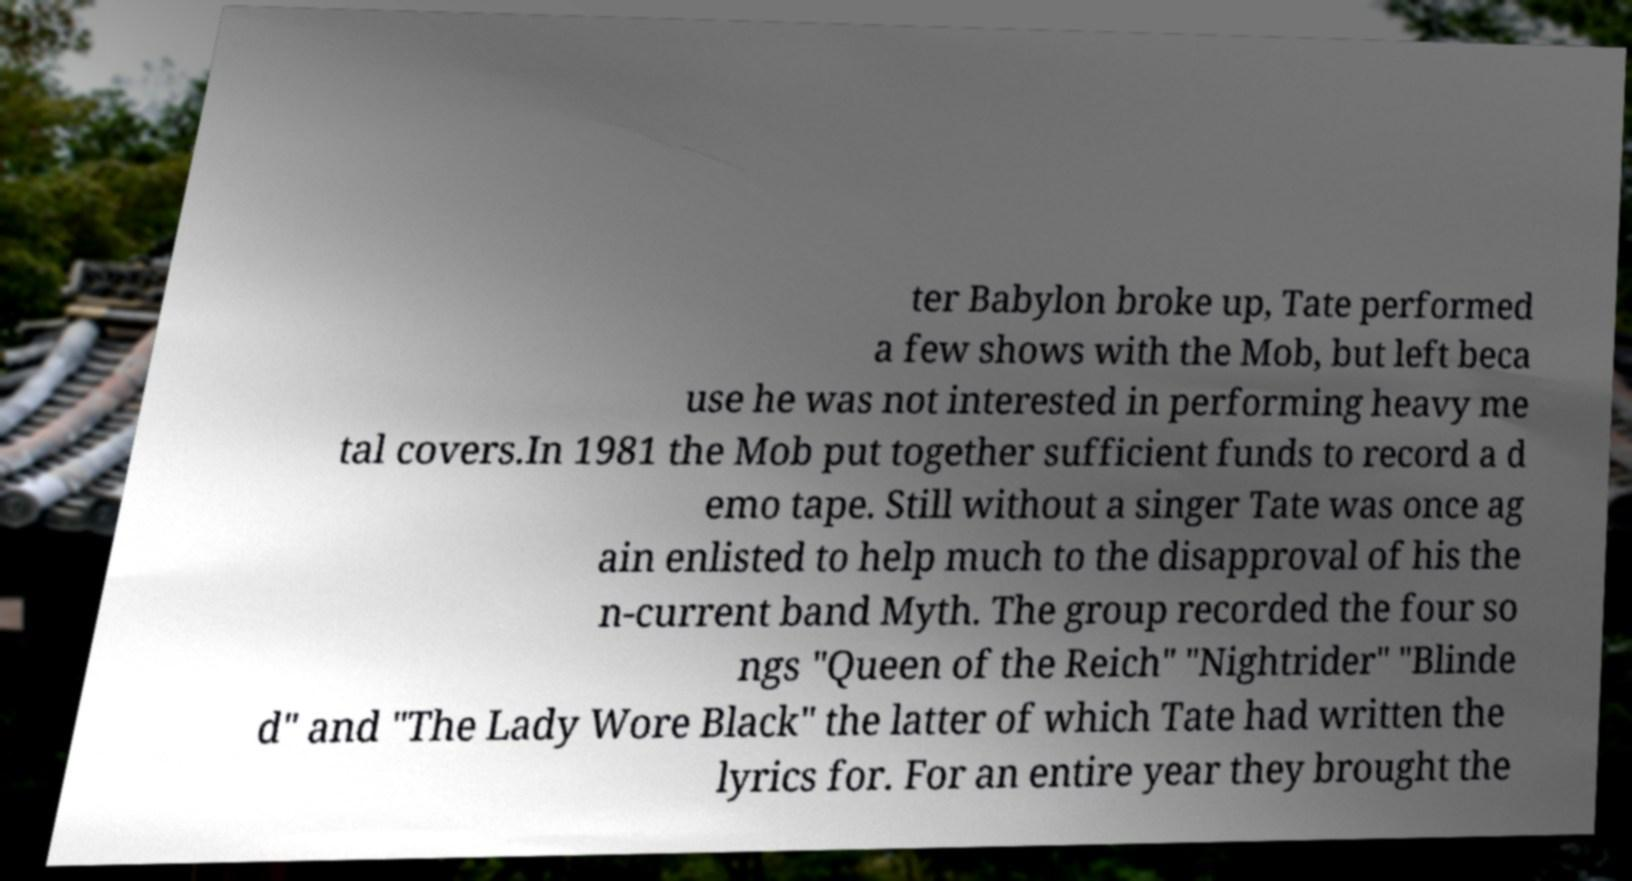Could you assist in decoding the text presented in this image and type it out clearly? ter Babylon broke up, Tate performed a few shows with the Mob, but left beca use he was not interested in performing heavy me tal covers.In 1981 the Mob put together sufficient funds to record a d emo tape. Still without a singer Tate was once ag ain enlisted to help much to the disapproval of his the n-current band Myth. The group recorded the four so ngs "Queen of the Reich" "Nightrider" "Blinde d" and "The Lady Wore Black" the latter of which Tate had written the lyrics for. For an entire year they brought the 